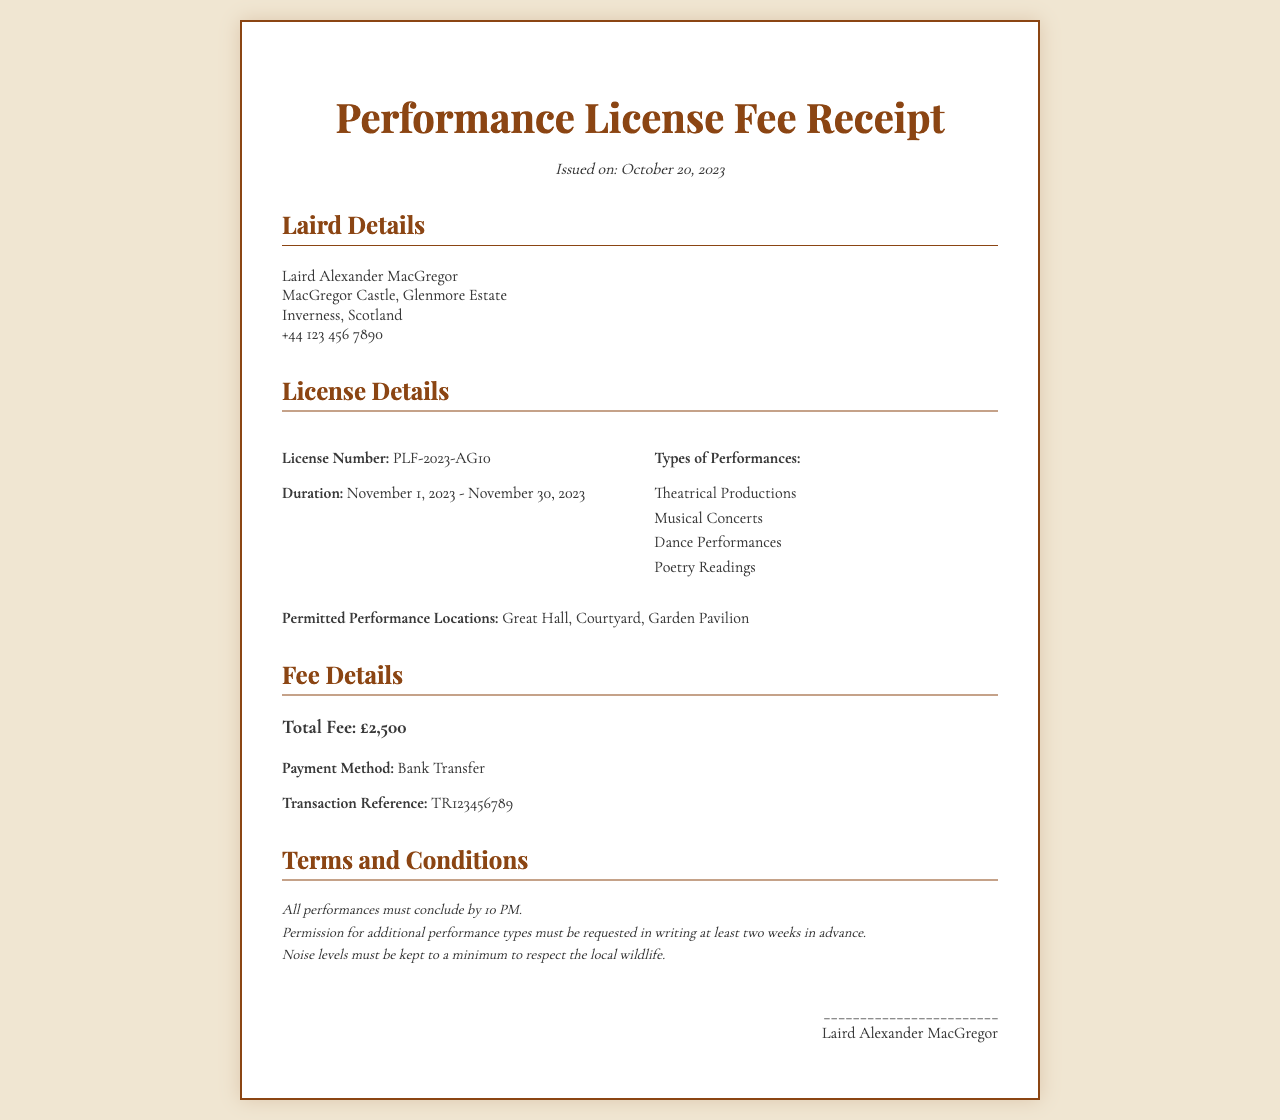What is the license number? The license number is specified in the document under License Details.
Answer: PLF-2023-AG10 What is the total fee? The total fee is highlighted in the Fee Details section of the document.
Answer: £2,500 What are the permitted performance locations? The document details the locations where performances are allowed in the License Details section.
Answer: Great Hall, Courtyard, Garden Pavilion How long is the duration of the license? The duration is indicated in the License Details section, specifying the start and end dates.
Answer: November 1, 2023 - November 30, 2023 What types of performances are allowed? The different types of performances permitted are listed in the License Details section.
Answer: Theatrical Productions, Musical Concerts, Dance Performances, Poetry Readings What is the payment method? The method for payment is mentioned in the Fee Details section of the document.
Answer: Bank Transfer Is there a noise restriction mentioned? Noise restrictions are stated as part of the terms and conditions in the document.
Answer: Yes What must be requested in writing? The requirement for additional permissions is outlined in the Terms and Conditions section.
Answer: Additional performance types What time must all performances conclude? The conclusion time for performances is stated in the Terms and Conditions part of the document.
Answer: 10 PM 